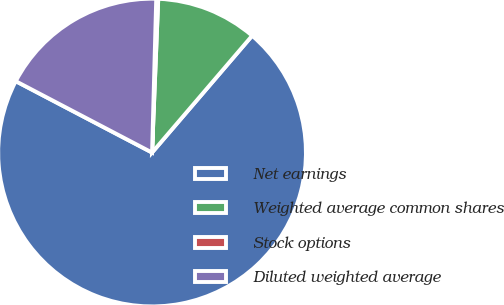Convert chart. <chart><loc_0><loc_0><loc_500><loc_500><pie_chart><fcel>Net earnings<fcel>Weighted average common shares<fcel>Stock options<fcel>Diluted weighted average<nl><fcel>71.4%<fcel>10.63%<fcel>0.21%<fcel>17.75%<nl></chart> 